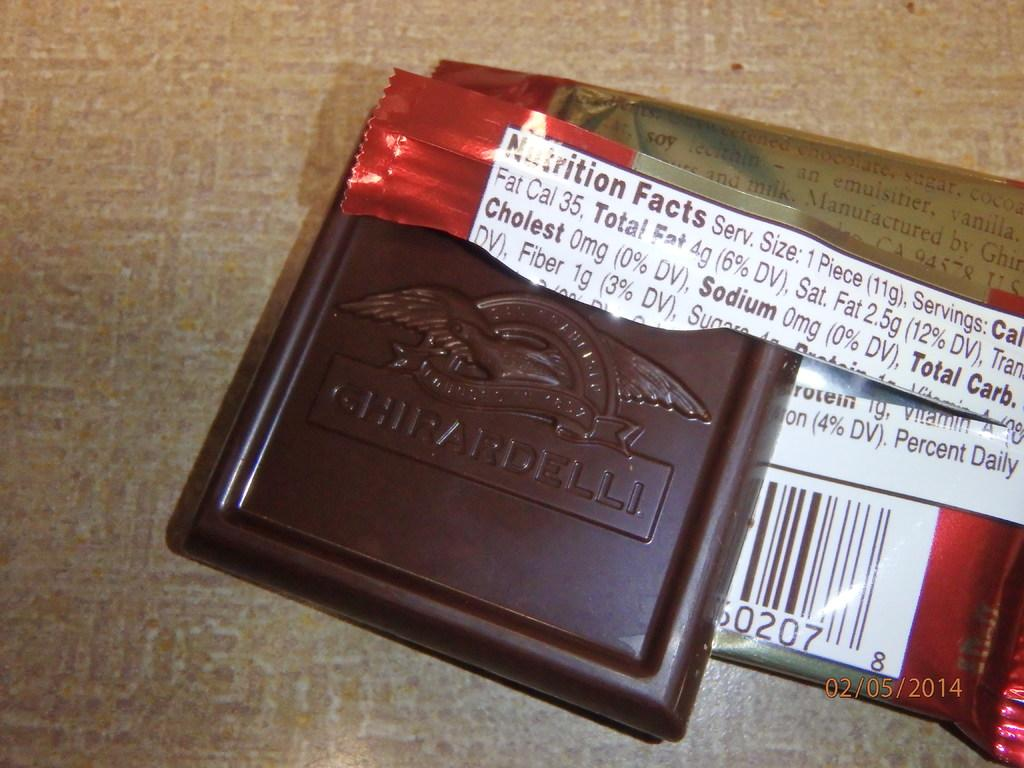What is the main subject of the image? The main subject of the image is a piece of chocolate. Does the chocolate have any packaging? Yes, the chocolate has a wrapper. Where is the chocolate and wrapper located? The chocolate and wrapper are present on a table. What type of ink is used to write on the chocolate wrapper in the image? There is no writing on the chocolate wrapper in the image, so it is not possible to determine the type of ink used. 